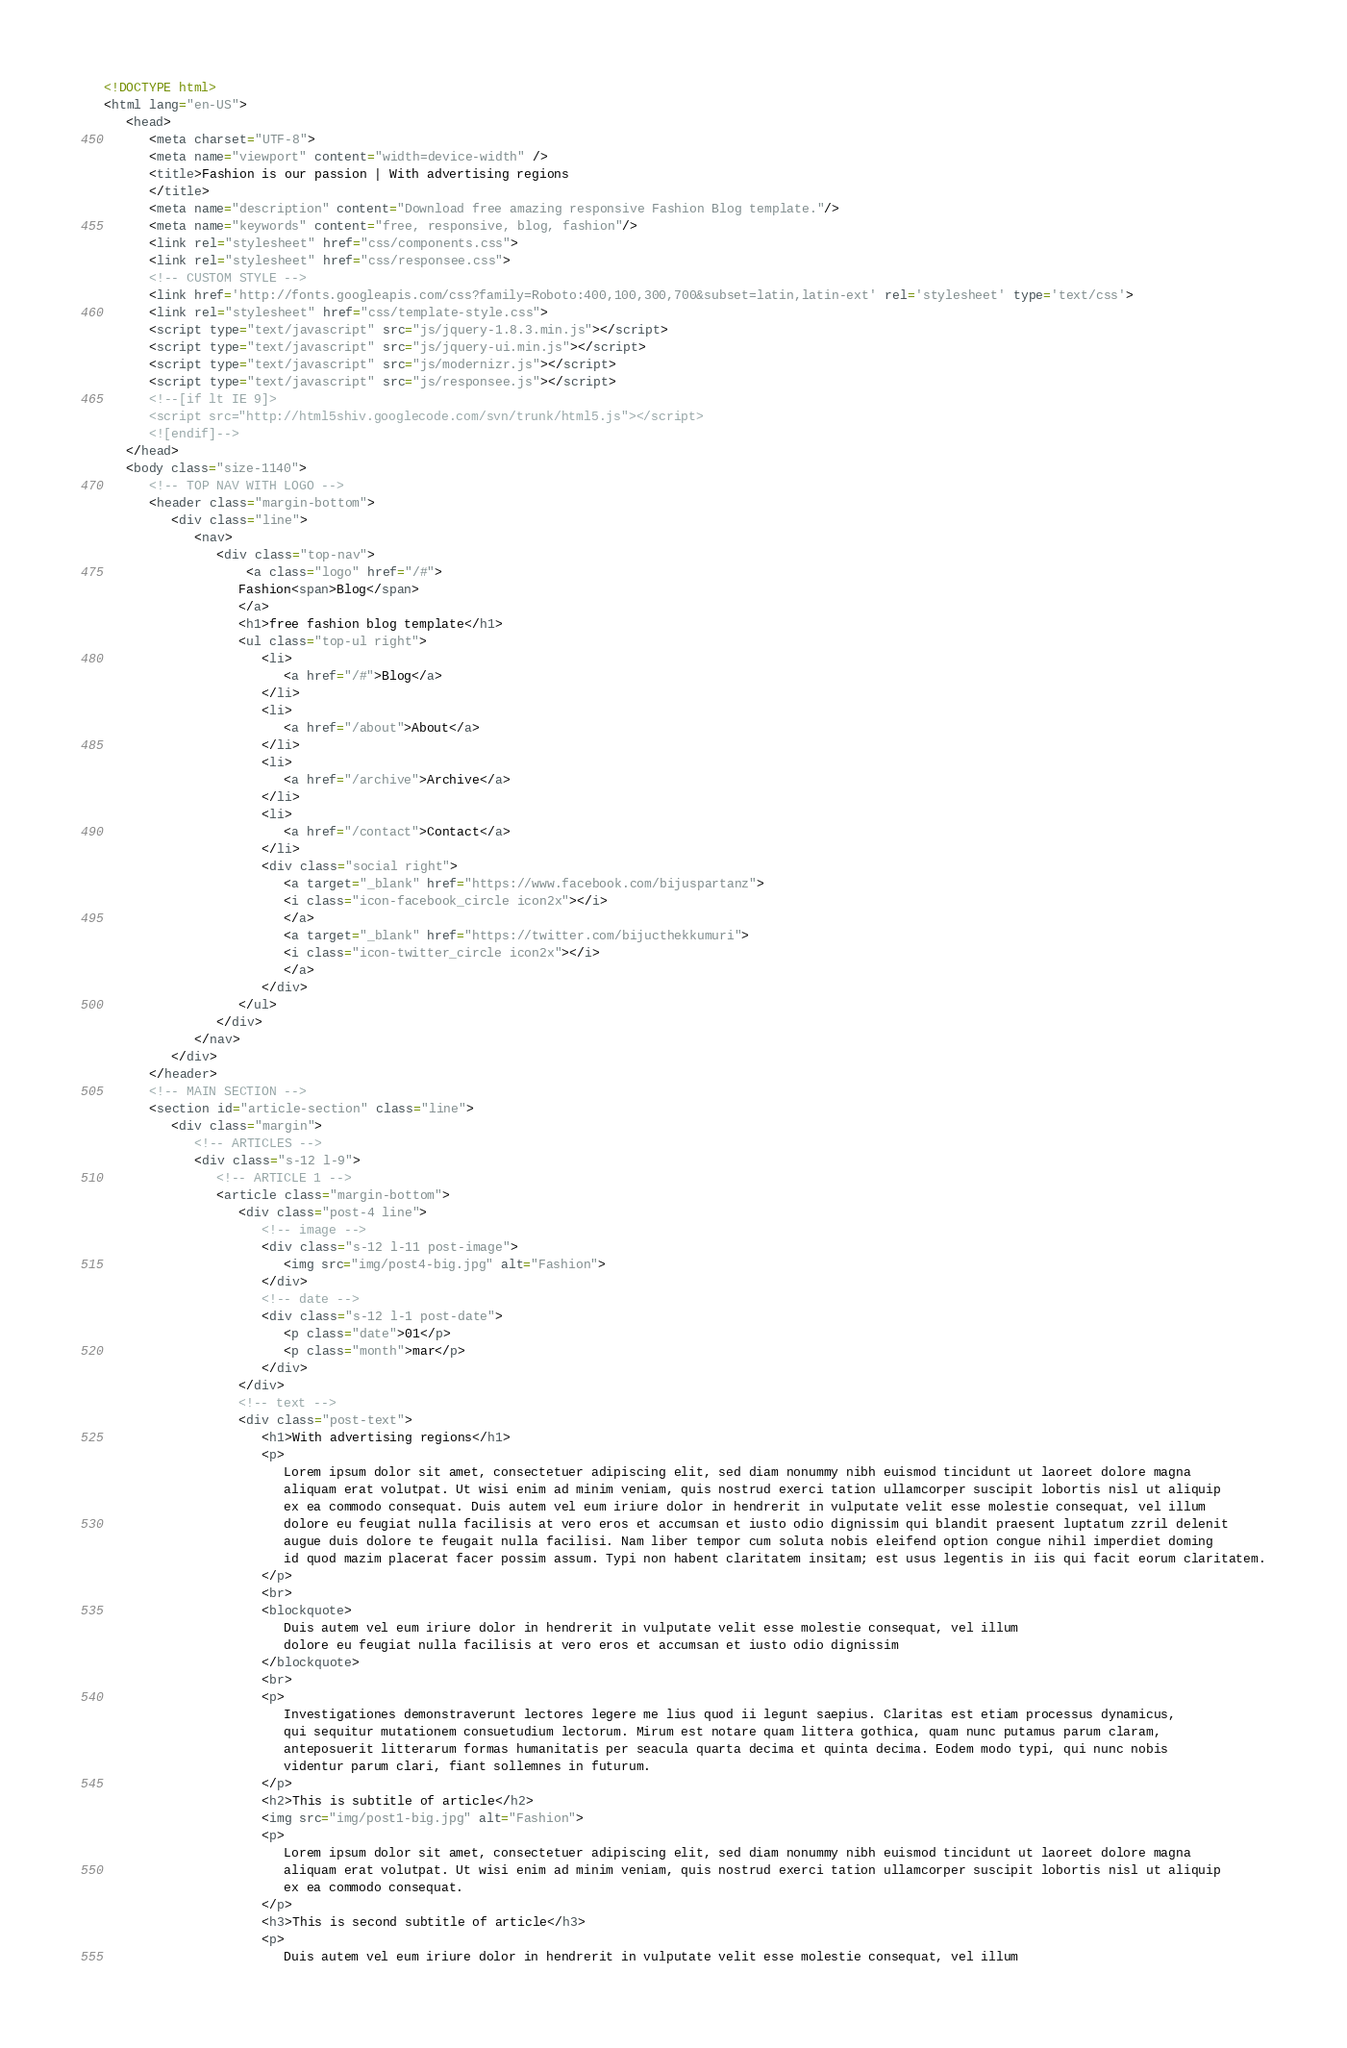Convert code to text. <code><loc_0><loc_0><loc_500><loc_500><_HTML_><!DOCTYPE html>
<html lang="en-US">
   <head>
      <meta charset="UTF-8">
      <meta name="viewport" content="width=device-width" />
      <title>Fashion is our passion | With advertising regions
      </title>
      <meta name="description" content="Download free amazing responsive Fashion Blog template."/>
      <meta name="keywords" content="free, responsive, blog, fashion"/>
      <link rel="stylesheet" href="css/components.css">
      <link rel="stylesheet" href="css/responsee.css">
      <!-- CUSTOM STYLE -->       
      <link href='http://fonts.googleapis.com/css?family=Roboto:400,100,300,700&subset=latin,latin-ext' rel='stylesheet' type='text/css'>
      <link rel="stylesheet" href="css/template-style.css">
      <script type="text/javascript" src="js/jquery-1.8.3.min.js"></script>
      <script type="text/javascript" src="js/jquery-ui.min.js"></script>    
      <script type="text/javascript" src="js/modernizr.js"></script>
      <script type="text/javascript" src="js/responsee.js"></script>         
      <!--[if lt IE 9]> 
      <script src="http://html5shiv.googlecode.com/svn/trunk/html5.js"></script> 
      <![endif]-->     
   </head>
   <body class="size-1140">
      <!-- TOP NAV WITH LOGO -->          
      <header class="margin-bottom">
         <div class="line">
            <nav>
               <div class="top-nav">
                   <a class="logo" href="/#">            
                  Fashion<span>Blog</span>
                  </a>            
                  <h1>free fashion blog template</h1>
                  <ul class="top-ul right">
                     <li>            
                        <a href="/#">Blog</a>
                     </li>
                     <li>            
                        <a href="/about">About</a>
                     </li>
                     <li>            
                        <a href="/archive">Archive</a>            
                     </li>
                     <li>            
                        <a href="/contact">Contact</a>            
                     </li>
                     <div class="social right">	           
                        <a target="_blank" href="https://www.facebook.com/bijuspartanz">
                        <i class="icon-facebook_circle icon2x"></i>
                        </a>          
                        <a target="_blank" href="https://twitter.com/bijucthekkumuri">
                        <i class="icon-twitter_circle icon2x"></i>
                        </a>          
                     </div>
                  </ul>
               </div>
            </nav>
         </div>
      </header>
      <!-- MAIN SECTION -->                  
      <section id="article-section" class="line">
         <div class="margin">
            <!-- ARTICLES -->             
            <div class="s-12 l-9">
               <!-- ARTICLE 1 -->               
               <article class="margin-bottom">
                  <div class="post-4 line">
                     <!-- image -->                 
                     <div class="s-12 l-11 post-image">                   
                        <img src="img/post4-big.jpg" alt="Fashion">              
                     </div>
                     <!-- date -->                 
                     <div class="s-12 l-1 post-date">
                        <p class="date">01</p>
                        <p class="month">mar</p>
                     </div>
                  </div>
                  <!-- text -->                 
                  <div class="post-text">
                     <h1>With advertising regions</h1>
                     <p>
                        Lorem ipsum dolor sit amet, consectetuer adipiscing elit, sed diam nonummy nibh euismod tincidunt ut laoreet dolore magna 
                        aliquam erat volutpat. Ut wisi enim ad minim veniam, quis nostrud exerci tation ullamcorper suscipit lobortis nisl ut aliquip 
                        ex ea commodo consequat. Duis autem vel eum iriure dolor in hendrerit in vulputate velit esse molestie consequat, vel illum 
                        dolore eu feugiat nulla facilisis at vero eros et accumsan et iusto odio dignissim qui blandit praesent luptatum zzril delenit 
                        augue duis dolore te feugait nulla facilisi. Nam liber tempor cum soluta nobis eleifend option congue nihil imperdiet doming 
                        id quod mazim placerat facer possim assum. Typi non habent claritatem insitam; est usus legentis in iis qui facit eorum claritatem.
                     </p>
                     <br>
                     <blockquote>
                        Duis autem vel eum iriure dolor in hendrerit in vulputate velit esse molestie consequat, vel illum 
                        dolore eu feugiat nulla facilisis at vero eros et accumsan et iusto odio dignissim
                     </blockquote>
                     <br>
                     <p> 
                        Investigationes demonstraverunt lectores legere me lius quod ii legunt saepius. Claritas est etiam processus dynamicus, 
                        qui sequitur mutationem consuetudium lectorum. Mirum est notare quam littera gothica, quam nunc putamus parum claram, 
                        anteposuerit litterarum formas humanitatis per seacula quarta decima et quinta decima. Eodem modo typi, qui nunc nobis 
                        videntur parum clari, fiant sollemnes in futurum.             
                     </p>
                     <h2>This is subtitle of article</h2>
                     <img src="img/post1-big.jpg" alt="Fashion">
                     <p>
                        Lorem ipsum dolor sit amet, consectetuer adipiscing elit, sed diam nonummy nibh euismod tincidunt ut laoreet dolore magna 
                        aliquam erat volutpat. Ut wisi enim ad minim veniam, quis nostrud exerci tation ullamcorper suscipit lobortis nisl ut aliquip 
                        ex ea commodo consequat.
                     </p>
                     <h3>This is second subtitle of article</h3>
                     <p>
                        Duis autem vel eum iriure dolor in hendrerit in vulputate velit esse molestie consequat, vel illum </code> 